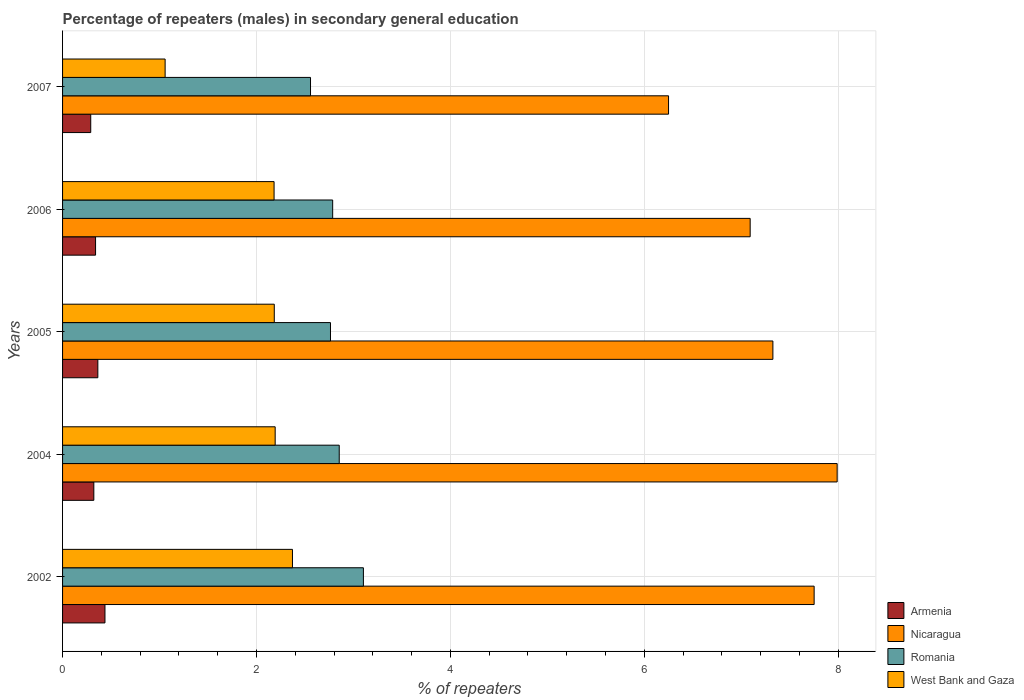How many groups of bars are there?
Your response must be concise. 5. Are the number of bars on each tick of the Y-axis equal?
Offer a terse response. Yes. How many bars are there on the 2nd tick from the top?
Provide a short and direct response. 4. How many bars are there on the 3rd tick from the bottom?
Offer a terse response. 4. What is the label of the 4th group of bars from the top?
Give a very brief answer. 2004. What is the percentage of male repeaters in Romania in 2006?
Keep it short and to the point. 2.79. Across all years, what is the maximum percentage of male repeaters in Armenia?
Offer a very short reply. 0.44. Across all years, what is the minimum percentage of male repeaters in Nicaragua?
Provide a succinct answer. 6.25. In which year was the percentage of male repeaters in Nicaragua maximum?
Provide a short and direct response. 2004. What is the total percentage of male repeaters in Romania in the graph?
Provide a succinct answer. 14.06. What is the difference between the percentage of male repeaters in Nicaragua in 2004 and that in 2006?
Offer a very short reply. 0.9. What is the difference between the percentage of male repeaters in Nicaragua in 2007 and the percentage of male repeaters in Armenia in 2002?
Provide a succinct answer. 5.81. What is the average percentage of male repeaters in West Bank and Gaza per year?
Offer a terse response. 2. In the year 2004, what is the difference between the percentage of male repeaters in West Bank and Gaza and percentage of male repeaters in Nicaragua?
Your response must be concise. -5.8. In how many years, is the percentage of male repeaters in Armenia greater than 4.4 %?
Make the answer very short. 0. What is the ratio of the percentage of male repeaters in Armenia in 2002 to that in 2007?
Ensure brevity in your answer.  1.51. Is the percentage of male repeaters in West Bank and Gaza in 2004 less than that in 2005?
Your response must be concise. No. Is the difference between the percentage of male repeaters in West Bank and Gaza in 2005 and 2007 greater than the difference between the percentage of male repeaters in Nicaragua in 2005 and 2007?
Your answer should be very brief. Yes. What is the difference between the highest and the second highest percentage of male repeaters in Nicaragua?
Offer a terse response. 0.24. What is the difference between the highest and the lowest percentage of male repeaters in Nicaragua?
Give a very brief answer. 1.74. Is the sum of the percentage of male repeaters in Romania in 2004 and 2005 greater than the maximum percentage of male repeaters in Nicaragua across all years?
Your answer should be very brief. No. What does the 1st bar from the top in 2007 represents?
Provide a short and direct response. West Bank and Gaza. What does the 4th bar from the bottom in 2004 represents?
Ensure brevity in your answer.  West Bank and Gaza. Is it the case that in every year, the sum of the percentage of male repeaters in Nicaragua and percentage of male repeaters in Armenia is greater than the percentage of male repeaters in Romania?
Give a very brief answer. Yes. How many bars are there?
Ensure brevity in your answer.  20. How many years are there in the graph?
Offer a terse response. 5. What is the difference between two consecutive major ticks on the X-axis?
Make the answer very short. 2. Are the values on the major ticks of X-axis written in scientific E-notation?
Provide a short and direct response. No. Does the graph contain any zero values?
Your response must be concise. No. Does the graph contain grids?
Provide a short and direct response. Yes. Where does the legend appear in the graph?
Your answer should be compact. Bottom right. How are the legend labels stacked?
Provide a short and direct response. Vertical. What is the title of the graph?
Ensure brevity in your answer.  Percentage of repeaters (males) in secondary general education. What is the label or title of the X-axis?
Your answer should be compact. % of repeaters. What is the label or title of the Y-axis?
Make the answer very short. Years. What is the % of repeaters in Armenia in 2002?
Provide a short and direct response. 0.44. What is the % of repeaters in Nicaragua in 2002?
Provide a succinct answer. 7.75. What is the % of repeaters in Romania in 2002?
Offer a terse response. 3.1. What is the % of repeaters in West Bank and Gaza in 2002?
Offer a very short reply. 2.37. What is the % of repeaters in Armenia in 2004?
Provide a short and direct response. 0.32. What is the % of repeaters of Nicaragua in 2004?
Give a very brief answer. 7.99. What is the % of repeaters in Romania in 2004?
Your answer should be very brief. 2.85. What is the % of repeaters of West Bank and Gaza in 2004?
Your answer should be very brief. 2.19. What is the % of repeaters of Armenia in 2005?
Keep it short and to the point. 0.36. What is the % of repeaters of Nicaragua in 2005?
Your response must be concise. 7.33. What is the % of repeaters in Romania in 2005?
Provide a short and direct response. 2.76. What is the % of repeaters in West Bank and Gaza in 2005?
Make the answer very short. 2.18. What is the % of repeaters of Armenia in 2006?
Ensure brevity in your answer.  0.34. What is the % of repeaters in Nicaragua in 2006?
Offer a very short reply. 7.09. What is the % of repeaters of Romania in 2006?
Your answer should be very brief. 2.79. What is the % of repeaters in West Bank and Gaza in 2006?
Keep it short and to the point. 2.18. What is the % of repeaters in Armenia in 2007?
Ensure brevity in your answer.  0.29. What is the % of repeaters of Nicaragua in 2007?
Provide a short and direct response. 6.25. What is the % of repeaters in Romania in 2007?
Give a very brief answer. 2.56. What is the % of repeaters in West Bank and Gaza in 2007?
Your answer should be very brief. 1.06. Across all years, what is the maximum % of repeaters of Armenia?
Your answer should be compact. 0.44. Across all years, what is the maximum % of repeaters of Nicaragua?
Ensure brevity in your answer.  7.99. Across all years, what is the maximum % of repeaters in Romania?
Your answer should be very brief. 3.1. Across all years, what is the maximum % of repeaters in West Bank and Gaza?
Give a very brief answer. 2.37. Across all years, what is the minimum % of repeaters of Armenia?
Provide a succinct answer. 0.29. Across all years, what is the minimum % of repeaters in Nicaragua?
Your answer should be very brief. 6.25. Across all years, what is the minimum % of repeaters in Romania?
Provide a succinct answer. 2.56. Across all years, what is the minimum % of repeaters in West Bank and Gaza?
Your answer should be very brief. 1.06. What is the total % of repeaters of Armenia in the graph?
Provide a succinct answer. 1.75. What is the total % of repeaters of Nicaragua in the graph?
Your response must be concise. 36.41. What is the total % of repeaters of Romania in the graph?
Your answer should be very brief. 14.06. What is the total % of repeaters in West Bank and Gaza in the graph?
Your answer should be very brief. 9.99. What is the difference between the % of repeaters of Armenia in 2002 and that in 2004?
Ensure brevity in your answer.  0.11. What is the difference between the % of repeaters in Nicaragua in 2002 and that in 2004?
Ensure brevity in your answer.  -0.24. What is the difference between the % of repeaters of Romania in 2002 and that in 2004?
Offer a very short reply. 0.25. What is the difference between the % of repeaters of West Bank and Gaza in 2002 and that in 2004?
Your response must be concise. 0.18. What is the difference between the % of repeaters of Armenia in 2002 and that in 2005?
Your answer should be compact. 0.07. What is the difference between the % of repeaters in Nicaragua in 2002 and that in 2005?
Give a very brief answer. 0.43. What is the difference between the % of repeaters of Romania in 2002 and that in 2005?
Ensure brevity in your answer.  0.34. What is the difference between the % of repeaters of West Bank and Gaza in 2002 and that in 2005?
Offer a very short reply. 0.19. What is the difference between the % of repeaters of Armenia in 2002 and that in 2006?
Keep it short and to the point. 0.1. What is the difference between the % of repeaters in Nicaragua in 2002 and that in 2006?
Give a very brief answer. 0.66. What is the difference between the % of repeaters of Romania in 2002 and that in 2006?
Your answer should be compact. 0.32. What is the difference between the % of repeaters of West Bank and Gaza in 2002 and that in 2006?
Ensure brevity in your answer.  0.19. What is the difference between the % of repeaters in Armenia in 2002 and that in 2007?
Offer a very short reply. 0.15. What is the difference between the % of repeaters in Nicaragua in 2002 and that in 2007?
Your answer should be compact. 1.5. What is the difference between the % of repeaters of Romania in 2002 and that in 2007?
Make the answer very short. 0.55. What is the difference between the % of repeaters in West Bank and Gaza in 2002 and that in 2007?
Make the answer very short. 1.31. What is the difference between the % of repeaters in Armenia in 2004 and that in 2005?
Ensure brevity in your answer.  -0.04. What is the difference between the % of repeaters in Nicaragua in 2004 and that in 2005?
Offer a very short reply. 0.66. What is the difference between the % of repeaters of Romania in 2004 and that in 2005?
Make the answer very short. 0.09. What is the difference between the % of repeaters of West Bank and Gaza in 2004 and that in 2005?
Provide a succinct answer. 0.01. What is the difference between the % of repeaters in Armenia in 2004 and that in 2006?
Ensure brevity in your answer.  -0.02. What is the difference between the % of repeaters of Nicaragua in 2004 and that in 2006?
Your answer should be compact. 0.9. What is the difference between the % of repeaters in Romania in 2004 and that in 2006?
Ensure brevity in your answer.  0.07. What is the difference between the % of repeaters of West Bank and Gaza in 2004 and that in 2006?
Your response must be concise. 0.01. What is the difference between the % of repeaters of Armenia in 2004 and that in 2007?
Ensure brevity in your answer.  0.03. What is the difference between the % of repeaters of Nicaragua in 2004 and that in 2007?
Provide a short and direct response. 1.74. What is the difference between the % of repeaters of Romania in 2004 and that in 2007?
Your answer should be very brief. 0.3. What is the difference between the % of repeaters of West Bank and Gaza in 2004 and that in 2007?
Offer a very short reply. 1.14. What is the difference between the % of repeaters of Armenia in 2005 and that in 2006?
Your answer should be compact. 0.02. What is the difference between the % of repeaters of Nicaragua in 2005 and that in 2006?
Offer a very short reply. 0.23. What is the difference between the % of repeaters of Romania in 2005 and that in 2006?
Give a very brief answer. -0.02. What is the difference between the % of repeaters of West Bank and Gaza in 2005 and that in 2006?
Offer a very short reply. 0. What is the difference between the % of repeaters in Armenia in 2005 and that in 2007?
Your answer should be very brief. 0.07. What is the difference between the % of repeaters in Nicaragua in 2005 and that in 2007?
Provide a succinct answer. 1.08. What is the difference between the % of repeaters in Romania in 2005 and that in 2007?
Keep it short and to the point. 0.21. What is the difference between the % of repeaters in West Bank and Gaza in 2005 and that in 2007?
Your answer should be very brief. 1.13. What is the difference between the % of repeaters of Armenia in 2006 and that in 2007?
Your response must be concise. 0.05. What is the difference between the % of repeaters of Nicaragua in 2006 and that in 2007?
Keep it short and to the point. 0.84. What is the difference between the % of repeaters of Romania in 2006 and that in 2007?
Your response must be concise. 0.23. What is the difference between the % of repeaters in West Bank and Gaza in 2006 and that in 2007?
Your answer should be compact. 1.12. What is the difference between the % of repeaters of Armenia in 2002 and the % of repeaters of Nicaragua in 2004?
Offer a terse response. -7.55. What is the difference between the % of repeaters in Armenia in 2002 and the % of repeaters in Romania in 2004?
Give a very brief answer. -2.42. What is the difference between the % of repeaters of Armenia in 2002 and the % of repeaters of West Bank and Gaza in 2004?
Offer a very short reply. -1.76. What is the difference between the % of repeaters in Nicaragua in 2002 and the % of repeaters in Romania in 2004?
Ensure brevity in your answer.  4.9. What is the difference between the % of repeaters of Nicaragua in 2002 and the % of repeaters of West Bank and Gaza in 2004?
Ensure brevity in your answer.  5.56. What is the difference between the % of repeaters in Romania in 2002 and the % of repeaters in West Bank and Gaza in 2004?
Offer a terse response. 0.91. What is the difference between the % of repeaters in Armenia in 2002 and the % of repeaters in Nicaragua in 2005?
Your response must be concise. -6.89. What is the difference between the % of repeaters of Armenia in 2002 and the % of repeaters of Romania in 2005?
Ensure brevity in your answer.  -2.33. What is the difference between the % of repeaters in Armenia in 2002 and the % of repeaters in West Bank and Gaza in 2005?
Your answer should be very brief. -1.75. What is the difference between the % of repeaters of Nicaragua in 2002 and the % of repeaters of Romania in 2005?
Provide a succinct answer. 4.99. What is the difference between the % of repeaters of Nicaragua in 2002 and the % of repeaters of West Bank and Gaza in 2005?
Give a very brief answer. 5.57. What is the difference between the % of repeaters of Romania in 2002 and the % of repeaters of West Bank and Gaza in 2005?
Keep it short and to the point. 0.92. What is the difference between the % of repeaters in Armenia in 2002 and the % of repeaters in Nicaragua in 2006?
Offer a terse response. -6.66. What is the difference between the % of repeaters in Armenia in 2002 and the % of repeaters in Romania in 2006?
Make the answer very short. -2.35. What is the difference between the % of repeaters in Armenia in 2002 and the % of repeaters in West Bank and Gaza in 2006?
Offer a terse response. -1.74. What is the difference between the % of repeaters of Nicaragua in 2002 and the % of repeaters of Romania in 2006?
Your answer should be compact. 4.97. What is the difference between the % of repeaters of Nicaragua in 2002 and the % of repeaters of West Bank and Gaza in 2006?
Give a very brief answer. 5.57. What is the difference between the % of repeaters of Romania in 2002 and the % of repeaters of West Bank and Gaza in 2006?
Keep it short and to the point. 0.92. What is the difference between the % of repeaters of Armenia in 2002 and the % of repeaters of Nicaragua in 2007?
Your answer should be very brief. -5.81. What is the difference between the % of repeaters of Armenia in 2002 and the % of repeaters of Romania in 2007?
Provide a short and direct response. -2.12. What is the difference between the % of repeaters in Armenia in 2002 and the % of repeaters in West Bank and Gaza in 2007?
Offer a terse response. -0.62. What is the difference between the % of repeaters in Nicaragua in 2002 and the % of repeaters in Romania in 2007?
Keep it short and to the point. 5.19. What is the difference between the % of repeaters of Nicaragua in 2002 and the % of repeaters of West Bank and Gaza in 2007?
Offer a very short reply. 6.69. What is the difference between the % of repeaters in Romania in 2002 and the % of repeaters in West Bank and Gaza in 2007?
Offer a very short reply. 2.05. What is the difference between the % of repeaters of Armenia in 2004 and the % of repeaters of Nicaragua in 2005?
Give a very brief answer. -7. What is the difference between the % of repeaters of Armenia in 2004 and the % of repeaters of Romania in 2005?
Your answer should be compact. -2.44. What is the difference between the % of repeaters of Armenia in 2004 and the % of repeaters of West Bank and Gaza in 2005?
Your answer should be very brief. -1.86. What is the difference between the % of repeaters in Nicaragua in 2004 and the % of repeaters in Romania in 2005?
Offer a very short reply. 5.23. What is the difference between the % of repeaters in Nicaragua in 2004 and the % of repeaters in West Bank and Gaza in 2005?
Offer a very short reply. 5.81. What is the difference between the % of repeaters in Romania in 2004 and the % of repeaters in West Bank and Gaza in 2005?
Ensure brevity in your answer.  0.67. What is the difference between the % of repeaters of Armenia in 2004 and the % of repeaters of Nicaragua in 2006?
Your response must be concise. -6.77. What is the difference between the % of repeaters in Armenia in 2004 and the % of repeaters in Romania in 2006?
Provide a short and direct response. -2.46. What is the difference between the % of repeaters in Armenia in 2004 and the % of repeaters in West Bank and Gaza in 2006?
Ensure brevity in your answer.  -1.86. What is the difference between the % of repeaters of Nicaragua in 2004 and the % of repeaters of Romania in 2006?
Offer a terse response. 5.2. What is the difference between the % of repeaters of Nicaragua in 2004 and the % of repeaters of West Bank and Gaza in 2006?
Ensure brevity in your answer.  5.81. What is the difference between the % of repeaters of Romania in 2004 and the % of repeaters of West Bank and Gaza in 2006?
Make the answer very short. 0.67. What is the difference between the % of repeaters of Armenia in 2004 and the % of repeaters of Nicaragua in 2007?
Your response must be concise. -5.93. What is the difference between the % of repeaters of Armenia in 2004 and the % of repeaters of Romania in 2007?
Your answer should be compact. -2.24. What is the difference between the % of repeaters of Armenia in 2004 and the % of repeaters of West Bank and Gaza in 2007?
Your response must be concise. -0.74. What is the difference between the % of repeaters of Nicaragua in 2004 and the % of repeaters of Romania in 2007?
Your response must be concise. 5.43. What is the difference between the % of repeaters in Nicaragua in 2004 and the % of repeaters in West Bank and Gaza in 2007?
Your answer should be compact. 6.93. What is the difference between the % of repeaters of Romania in 2004 and the % of repeaters of West Bank and Gaza in 2007?
Keep it short and to the point. 1.8. What is the difference between the % of repeaters of Armenia in 2005 and the % of repeaters of Nicaragua in 2006?
Make the answer very short. -6.73. What is the difference between the % of repeaters of Armenia in 2005 and the % of repeaters of Romania in 2006?
Ensure brevity in your answer.  -2.42. What is the difference between the % of repeaters of Armenia in 2005 and the % of repeaters of West Bank and Gaza in 2006?
Offer a very short reply. -1.82. What is the difference between the % of repeaters in Nicaragua in 2005 and the % of repeaters in Romania in 2006?
Your response must be concise. 4.54. What is the difference between the % of repeaters in Nicaragua in 2005 and the % of repeaters in West Bank and Gaza in 2006?
Offer a very short reply. 5.15. What is the difference between the % of repeaters of Romania in 2005 and the % of repeaters of West Bank and Gaza in 2006?
Give a very brief answer. 0.58. What is the difference between the % of repeaters of Armenia in 2005 and the % of repeaters of Nicaragua in 2007?
Offer a terse response. -5.89. What is the difference between the % of repeaters of Armenia in 2005 and the % of repeaters of Romania in 2007?
Offer a terse response. -2.19. What is the difference between the % of repeaters of Armenia in 2005 and the % of repeaters of West Bank and Gaza in 2007?
Ensure brevity in your answer.  -0.69. What is the difference between the % of repeaters in Nicaragua in 2005 and the % of repeaters in Romania in 2007?
Your answer should be very brief. 4.77. What is the difference between the % of repeaters of Nicaragua in 2005 and the % of repeaters of West Bank and Gaza in 2007?
Offer a terse response. 6.27. What is the difference between the % of repeaters of Romania in 2005 and the % of repeaters of West Bank and Gaza in 2007?
Provide a succinct answer. 1.71. What is the difference between the % of repeaters of Armenia in 2006 and the % of repeaters of Nicaragua in 2007?
Your answer should be very brief. -5.91. What is the difference between the % of repeaters of Armenia in 2006 and the % of repeaters of Romania in 2007?
Your response must be concise. -2.22. What is the difference between the % of repeaters of Armenia in 2006 and the % of repeaters of West Bank and Gaza in 2007?
Your response must be concise. -0.72. What is the difference between the % of repeaters in Nicaragua in 2006 and the % of repeaters in Romania in 2007?
Offer a terse response. 4.54. What is the difference between the % of repeaters in Nicaragua in 2006 and the % of repeaters in West Bank and Gaza in 2007?
Make the answer very short. 6.03. What is the difference between the % of repeaters in Romania in 2006 and the % of repeaters in West Bank and Gaza in 2007?
Keep it short and to the point. 1.73. What is the average % of repeaters of Armenia per year?
Provide a short and direct response. 0.35. What is the average % of repeaters in Nicaragua per year?
Ensure brevity in your answer.  7.28. What is the average % of repeaters in Romania per year?
Provide a short and direct response. 2.81. What is the average % of repeaters of West Bank and Gaza per year?
Provide a short and direct response. 2. In the year 2002, what is the difference between the % of repeaters in Armenia and % of repeaters in Nicaragua?
Provide a succinct answer. -7.32. In the year 2002, what is the difference between the % of repeaters of Armenia and % of repeaters of Romania?
Your response must be concise. -2.67. In the year 2002, what is the difference between the % of repeaters in Armenia and % of repeaters in West Bank and Gaza?
Provide a short and direct response. -1.93. In the year 2002, what is the difference between the % of repeaters of Nicaragua and % of repeaters of Romania?
Your answer should be very brief. 4.65. In the year 2002, what is the difference between the % of repeaters in Nicaragua and % of repeaters in West Bank and Gaza?
Your answer should be very brief. 5.38. In the year 2002, what is the difference between the % of repeaters of Romania and % of repeaters of West Bank and Gaza?
Offer a terse response. 0.73. In the year 2004, what is the difference between the % of repeaters in Armenia and % of repeaters in Nicaragua?
Keep it short and to the point. -7.67. In the year 2004, what is the difference between the % of repeaters in Armenia and % of repeaters in Romania?
Give a very brief answer. -2.53. In the year 2004, what is the difference between the % of repeaters in Armenia and % of repeaters in West Bank and Gaza?
Offer a terse response. -1.87. In the year 2004, what is the difference between the % of repeaters of Nicaragua and % of repeaters of Romania?
Your answer should be very brief. 5.14. In the year 2004, what is the difference between the % of repeaters in Nicaragua and % of repeaters in West Bank and Gaza?
Offer a very short reply. 5.8. In the year 2004, what is the difference between the % of repeaters in Romania and % of repeaters in West Bank and Gaza?
Your answer should be very brief. 0.66. In the year 2005, what is the difference between the % of repeaters of Armenia and % of repeaters of Nicaragua?
Provide a succinct answer. -6.96. In the year 2005, what is the difference between the % of repeaters of Armenia and % of repeaters of Romania?
Your answer should be compact. -2.4. In the year 2005, what is the difference between the % of repeaters in Armenia and % of repeaters in West Bank and Gaza?
Provide a succinct answer. -1.82. In the year 2005, what is the difference between the % of repeaters of Nicaragua and % of repeaters of Romania?
Ensure brevity in your answer.  4.56. In the year 2005, what is the difference between the % of repeaters in Nicaragua and % of repeaters in West Bank and Gaza?
Give a very brief answer. 5.14. In the year 2005, what is the difference between the % of repeaters in Romania and % of repeaters in West Bank and Gaza?
Give a very brief answer. 0.58. In the year 2006, what is the difference between the % of repeaters in Armenia and % of repeaters in Nicaragua?
Your answer should be compact. -6.75. In the year 2006, what is the difference between the % of repeaters in Armenia and % of repeaters in Romania?
Your answer should be compact. -2.45. In the year 2006, what is the difference between the % of repeaters of Armenia and % of repeaters of West Bank and Gaza?
Your answer should be very brief. -1.84. In the year 2006, what is the difference between the % of repeaters of Nicaragua and % of repeaters of Romania?
Your answer should be compact. 4.31. In the year 2006, what is the difference between the % of repeaters in Nicaragua and % of repeaters in West Bank and Gaza?
Your response must be concise. 4.91. In the year 2006, what is the difference between the % of repeaters of Romania and % of repeaters of West Bank and Gaza?
Give a very brief answer. 0.6. In the year 2007, what is the difference between the % of repeaters of Armenia and % of repeaters of Nicaragua?
Give a very brief answer. -5.96. In the year 2007, what is the difference between the % of repeaters in Armenia and % of repeaters in Romania?
Provide a succinct answer. -2.27. In the year 2007, what is the difference between the % of repeaters of Armenia and % of repeaters of West Bank and Gaza?
Give a very brief answer. -0.77. In the year 2007, what is the difference between the % of repeaters in Nicaragua and % of repeaters in Romania?
Offer a terse response. 3.69. In the year 2007, what is the difference between the % of repeaters of Nicaragua and % of repeaters of West Bank and Gaza?
Make the answer very short. 5.19. In the year 2007, what is the difference between the % of repeaters in Romania and % of repeaters in West Bank and Gaza?
Provide a short and direct response. 1.5. What is the ratio of the % of repeaters of Armenia in 2002 to that in 2004?
Offer a terse response. 1.36. What is the ratio of the % of repeaters in Nicaragua in 2002 to that in 2004?
Offer a very short reply. 0.97. What is the ratio of the % of repeaters of Romania in 2002 to that in 2004?
Give a very brief answer. 1.09. What is the ratio of the % of repeaters in West Bank and Gaza in 2002 to that in 2004?
Provide a succinct answer. 1.08. What is the ratio of the % of repeaters in Armenia in 2002 to that in 2005?
Give a very brief answer. 1.2. What is the ratio of the % of repeaters of Nicaragua in 2002 to that in 2005?
Offer a very short reply. 1.06. What is the ratio of the % of repeaters of Romania in 2002 to that in 2005?
Your response must be concise. 1.12. What is the ratio of the % of repeaters of West Bank and Gaza in 2002 to that in 2005?
Give a very brief answer. 1.09. What is the ratio of the % of repeaters in Armenia in 2002 to that in 2006?
Provide a succinct answer. 1.28. What is the ratio of the % of repeaters of Nicaragua in 2002 to that in 2006?
Keep it short and to the point. 1.09. What is the ratio of the % of repeaters of Romania in 2002 to that in 2006?
Provide a succinct answer. 1.11. What is the ratio of the % of repeaters in West Bank and Gaza in 2002 to that in 2006?
Your response must be concise. 1.09. What is the ratio of the % of repeaters in Armenia in 2002 to that in 2007?
Offer a terse response. 1.51. What is the ratio of the % of repeaters in Nicaragua in 2002 to that in 2007?
Provide a short and direct response. 1.24. What is the ratio of the % of repeaters of Romania in 2002 to that in 2007?
Provide a succinct answer. 1.21. What is the ratio of the % of repeaters in West Bank and Gaza in 2002 to that in 2007?
Offer a terse response. 2.24. What is the ratio of the % of repeaters of Armenia in 2004 to that in 2005?
Provide a short and direct response. 0.89. What is the ratio of the % of repeaters of Nicaragua in 2004 to that in 2005?
Make the answer very short. 1.09. What is the ratio of the % of repeaters of Romania in 2004 to that in 2005?
Give a very brief answer. 1.03. What is the ratio of the % of repeaters of Armenia in 2004 to that in 2006?
Your response must be concise. 0.95. What is the ratio of the % of repeaters of Nicaragua in 2004 to that in 2006?
Your response must be concise. 1.13. What is the ratio of the % of repeaters of Romania in 2004 to that in 2006?
Your answer should be compact. 1.02. What is the ratio of the % of repeaters in Armenia in 2004 to that in 2007?
Your response must be concise. 1.11. What is the ratio of the % of repeaters of Nicaragua in 2004 to that in 2007?
Give a very brief answer. 1.28. What is the ratio of the % of repeaters of Romania in 2004 to that in 2007?
Provide a succinct answer. 1.12. What is the ratio of the % of repeaters in West Bank and Gaza in 2004 to that in 2007?
Provide a succinct answer. 2.07. What is the ratio of the % of repeaters of Armenia in 2005 to that in 2006?
Keep it short and to the point. 1.07. What is the ratio of the % of repeaters of Nicaragua in 2005 to that in 2006?
Offer a terse response. 1.03. What is the ratio of the % of repeaters in Romania in 2005 to that in 2006?
Give a very brief answer. 0.99. What is the ratio of the % of repeaters of West Bank and Gaza in 2005 to that in 2006?
Give a very brief answer. 1. What is the ratio of the % of repeaters in Armenia in 2005 to that in 2007?
Provide a short and direct response. 1.25. What is the ratio of the % of repeaters in Nicaragua in 2005 to that in 2007?
Ensure brevity in your answer.  1.17. What is the ratio of the % of repeaters of Romania in 2005 to that in 2007?
Your response must be concise. 1.08. What is the ratio of the % of repeaters in West Bank and Gaza in 2005 to that in 2007?
Provide a succinct answer. 2.06. What is the ratio of the % of repeaters of Armenia in 2006 to that in 2007?
Ensure brevity in your answer.  1.17. What is the ratio of the % of repeaters in Nicaragua in 2006 to that in 2007?
Ensure brevity in your answer.  1.13. What is the ratio of the % of repeaters in Romania in 2006 to that in 2007?
Keep it short and to the point. 1.09. What is the ratio of the % of repeaters of West Bank and Gaza in 2006 to that in 2007?
Keep it short and to the point. 2.06. What is the difference between the highest and the second highest % of repeaters in Armenia?
Offer a terse response. 0.07. What is the difference between the highest and the second highest % of repeaters in Nicaragua?
Provide a short and direct response. 0.24. What is the difference between the highest and the second highest % of repeaters of Romania?
Offer a very short reply. 0.25. What is the difference between the highest and the second highest % of repeaters in West Bank and Gaza?
Provide a short and direct response. 0.18. What is the difference between the highest and the lowest % of repeaters of Armenia?
Offer a very short reply. 0.15. What is the difference between the highest and the lowest % of repeaters of Nicaragua?
Your answer should be very brief. 1.74. What is the difference between the highest and the lowest % of repeaters in Romania?
Keep it short and to the point. 0.55. What is the difference between the highest and the lowest % of repeaters in West Bank and Gaza?
Offer a very short reply. 1.31. 